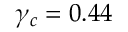<formula> <loc_0><loc_0><loc_500><loc_500>\gamma _ { c } = 0 . 4 4</formula> 